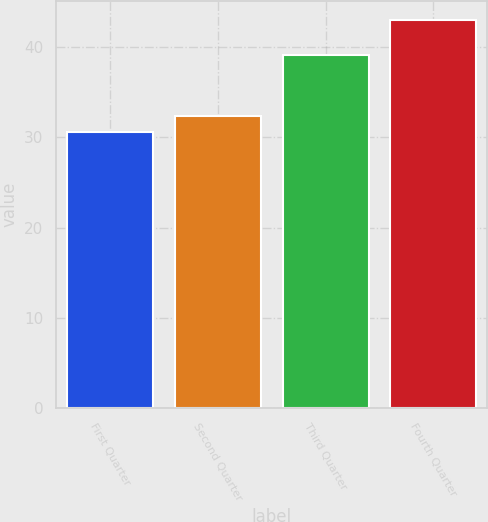<chart> <loc_0><loc_0><loc_500><loc_500><bar_chart><fcel>First Quarter<fcel>Second Quarter<fcel>Third Quarter<fcel>Fourth Quarter<nl><fcel>30.51<fcel>32.29<fcel>39.05<fcel>42.9<nl></chart> 